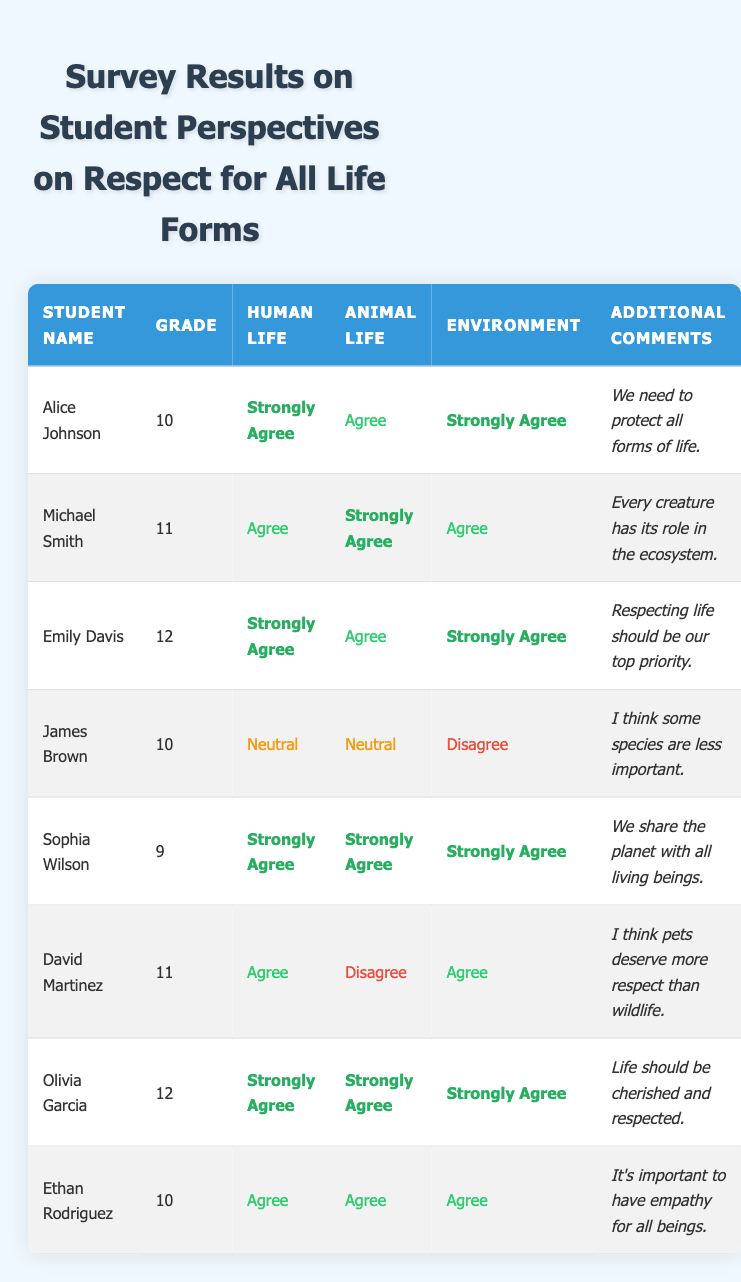What percentage of students strongly agree with the perspective on human life? There are 8 students in total. Out of these, 5 (Alice Johnson, Emily Davis, Sophia Wilson, Olivia Garcia) chose "Strongly Agree" for human life. To calculate the percentage: (5/8) * 100 = 62.5%.
Answer: 62.5% How many students agreed with the perspective on animal life? By reviewing the table, we see that 4 students (Alice Johnson, Michael Smith, Emily Davis, Sophia Wilson, Olivia Garcia) say "Agree" or "Strongly Agree". Counting these gives us 6 agree (Alice, Michael, Sophia, Olivia) and 1 disagree (David) for the animal life perspective, so total agreeing students are 6.
Answer: 6 Which grade has the highest number of students expressing "Strongly Agree" for the environment? Upon examining the table, there are 5 students expressing "Strongly Agree" for the environment. Among them, 2 are in grade 12 (Emily Davis and Olivia Garcia), 2 are in grade 10 (Alice Johnson, Sophia Wilson), and 0 in grade 11. Thus, grade 12 has the most students at 2.
Answer: Grade 12 Is there a student who disagrees with the perspective on the environment while also agreeing on animal life? Reviewing the table, David Martinez disagrees with the environment but agrees on human life. Thus, the statement holds true.
Answer: Yes What is the average response regarding perspectives on human life among all grades? We classify the perspectives on human life as follows: "Strongly Agree" = 4 points, "Agree" = 3 points, "Neutral" = 2 points, and "Disagree" = 1 point. The students' responses are: 5 from "Strongly Agree" weighted as 4, 3 from "Agree" weighted as 3, 1 from "Neutral" weighted as 2. The total score is (5*4 + 3*3 + 2*2 + 1*1) = 20 + 9 + 2 + 1 = 32 out of a total of 8 students. Average is: 32/8 = 4.
Answer: 4 Which students are in grade 11 and what are their perspectives on life forms? In grade 11, Michael Smith and David Martinez are the students. Michael agrees on human life, strongly agrees on animal life, and agrees on environment. David agrees on human life, disagrees on animal life, and agrees on environment.
Answer: Michael Smith, David Martinez 